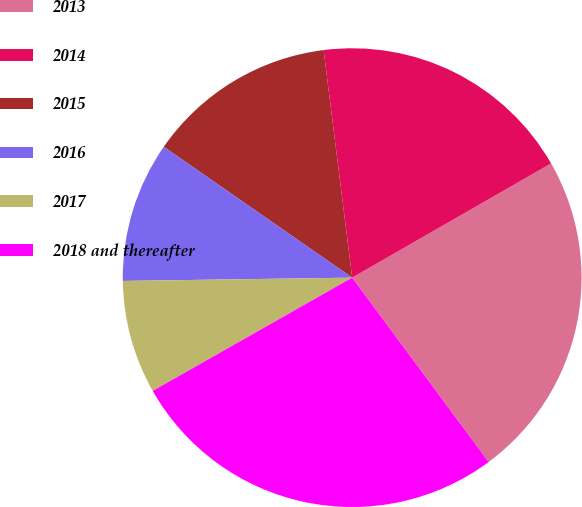Convert chart. <chart><loc_0><loc_0><loc_500><loc_500><pie_chart><fcel>2013<fcel>2014<fcel>2015<fcel>2016<fcel>2017<fcel>2018 and thereafter<nl><fcel>23.15%<fcel>18.69%<fcel>13.35%<fcel>9.89%<fcel>7.99%<fcel>26.92%<nl></chart> 